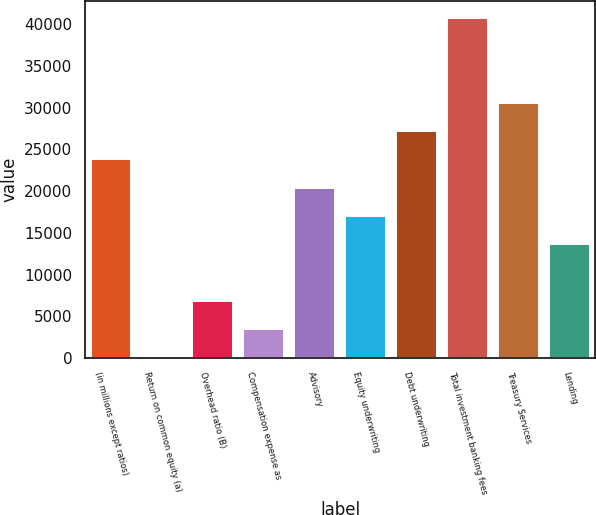<chart> <loc_0><loc_0><loc_500><loc_500><bar_chart><fcel>(in millions except ratios)<fcel>Return on common equity (a)<fcel>Overhead ratio (B)<fcel>Compensation expense as<fcel>Advisory<fcel>Equity underwriting<fcel>Debt underwriting<fcel>Total investment banking fees<fcel>Treasury Services<fcel>Lending<nl><fcel>23793.9<fcel>17<fcel>6810.4<fcel>3413.7<fcel>20397.2<fcel>17000.5<fcel>27190.6<fcel>40777.4<fcel>30587.3<fcel>13603.8<nl></chart> 